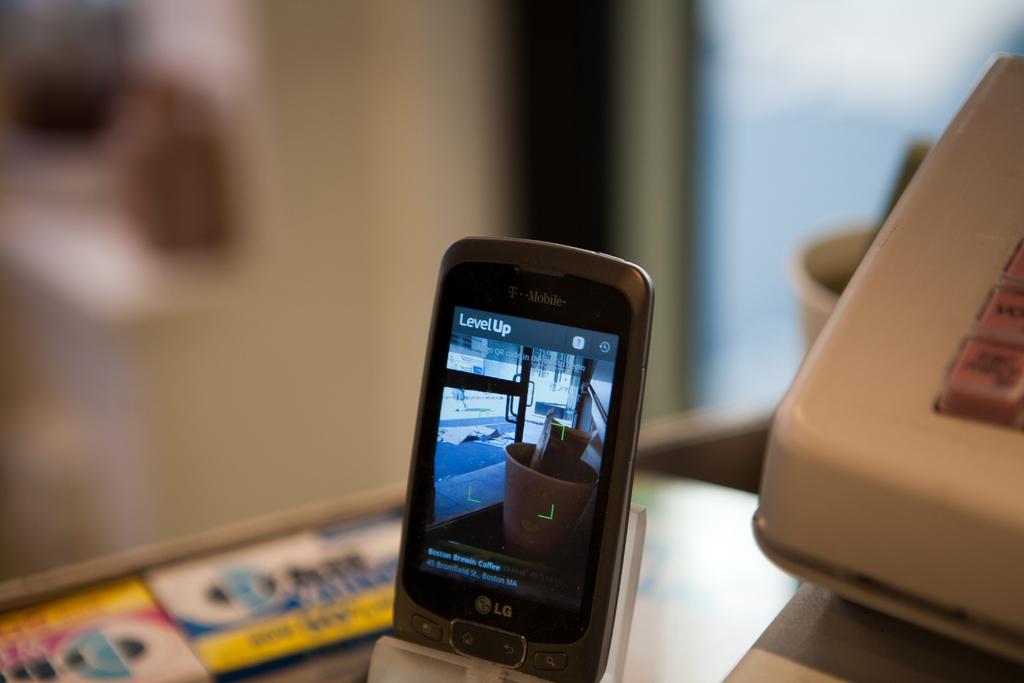What brand of smartphone is this?
Your answer should be very brief. Lg. What does the smartphone say on the top of the display?
Your answer should be compact. Levelup. 